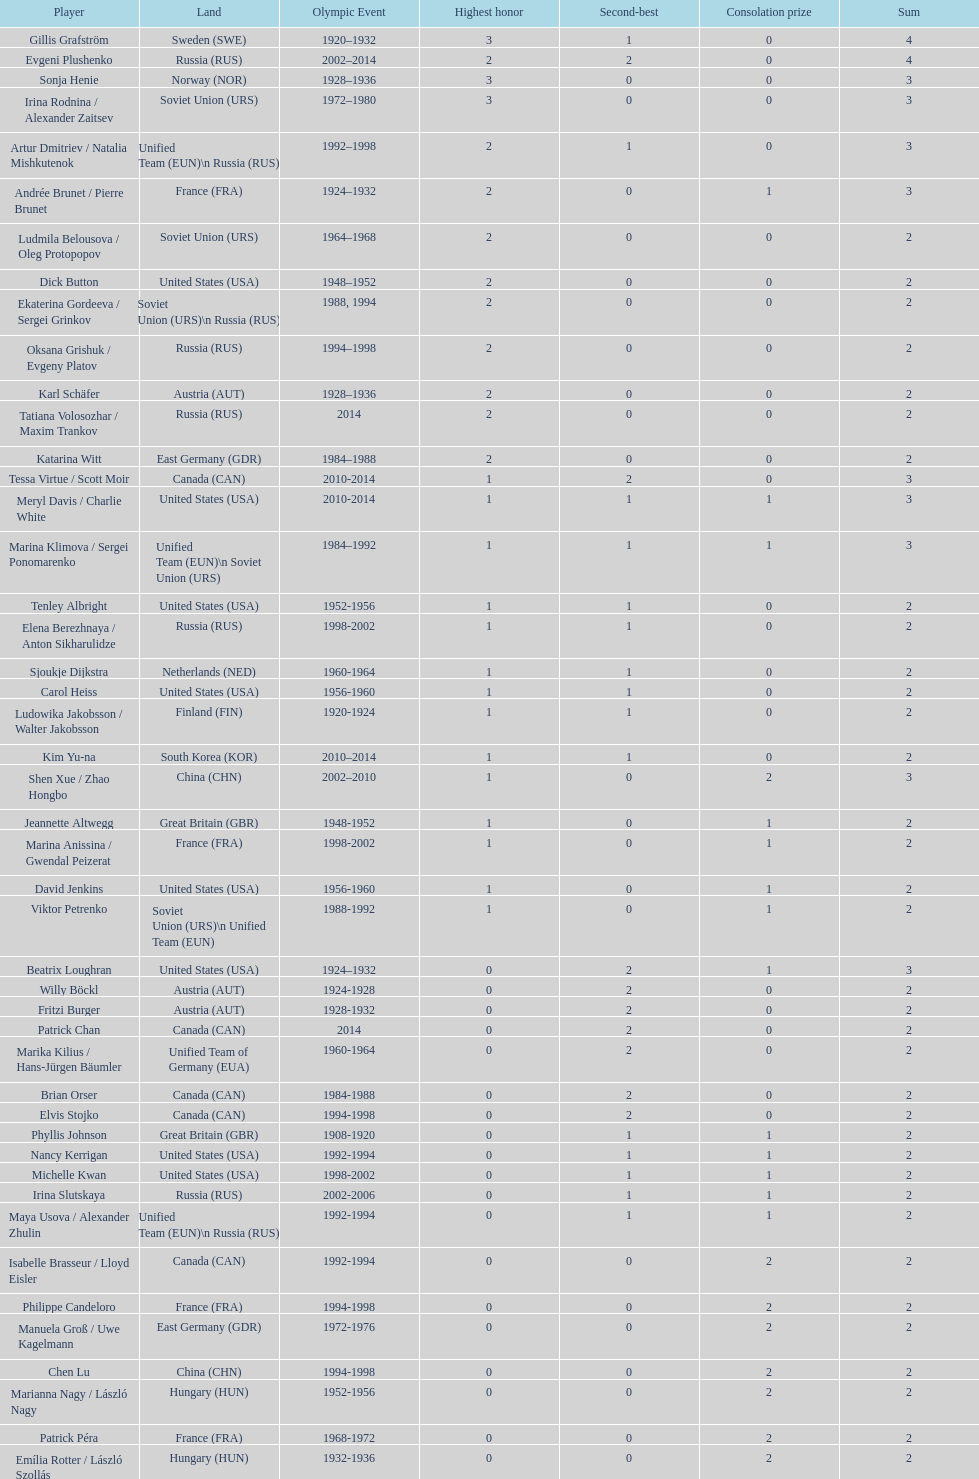Can you parse all the data within this table? {'header': ['Player', 'Land', 'Olympic Event', 'Highest honor', 'Second-best', 'Consolation prize', 'Sum'], 'rows': [['Gillis Grafström', 'Sweden\xa0(SWE)', '1920–1932', '3', '1', '0', '4'], ['Evgeni Plushenko', 'Russia\xa0(RUS)', '2002–2014', '2', '2', '0', '4'], ['Sonja Henie', 'Norway\xa0(NOR)', '1928–1936', '3', '0', '0', '3'], ['Irina Rodnina / Alexander Zaitsev', 'Soviet Union\xa0(URS)', '1972–1980', '3', '0', '0', '3'], ['Artur Dmitriev / Natalia Mishkutenok', 'Unified Team\xa0(EUN)\\n\xa0Russia\xa0(RUS)', '1992–1998', '2', '1', '0', '3'], ['Andrée Brunet / Pierre Brunet', 'France\xa0(FRA)', '1924–1932', '2', '0', '1', '3'], ['Ludmila Belousova / Oleg Protopopov', 'Soviet Union\xa0(URS)', '1964–1968', '2', '0', '0', '2'], ['Dick Button', 'United States\xa0(USA)', '1948–1952', '2', '0', '0', '2'], ['Ekaterina Gordeeva / Sergei Grinkov', 'Soviet Union\xa0(URS)\\n\xa0Russia\xa0(RUS)', '1988, 1994', '2', '0', '0', '2'], ['Oksana Grishuk / Evgeny Platov', 'Russia\xa0(RUS)', '1994–1998', '2', '0', '0', '2'], ['Karl Schäfer', 'Austria\xa0(AUT)', '1928–1936', '2', '0', '0', '2'], ['Tatiana Volosozhar / Maxim Trankov', 'Russia\xa0(RUS)', '2014', '2', '0', '0', '2'], ['Katarina Witt', 'East Germany\xa0(GDR)', '1984–1988', '2', '0', '0', '2'], ['Tessa Virtue / Scott Moir', 'Canada\xa0(CAN)', '2010-2014', '1', '2', '0', '3'], ['Meryl Davis / Charlie White', 'United States\xa0(USA)', '2010-2014', '1', '1', '1', '3'], ['Marina Klimova / Sergei Ponomarenko', 'Unified Team\xa0(EUN)\\n\xa0Soviet Union\xa0(URS)', '1984–1992', '1', '1', '1', '3'], ['Tenley Albright', 'United States\xa0(USA)', '1952-1956', '1', '1', '0', '2'], ['Elena Berezhnaya / Anton Sikharulidze', 'Russia\xa0(RUS)', '1998-2002', '1', '1', '0', '2'], ['Sjoukje Dijkstra', 'Netherlands\xa0(NED)', '1960-1964', '1', '1', '0', '2'], ['Carol Heiss', 'United States\xa0(USA)', '1956-1960', '1', '1', '0', '2'], ['Ludowika Jakobsson / Walter Jakobsson', 'Finland\xa0(FIN)', '1920-1924', '1', '1', '0', '2'], ['Kim Yu-na', 'South Korea\xa0(KOR)', '2010–2014', '1', '1', '0', '2'], ['Shen Xue / Zhao Hongbo', 'China\xa0(CHN)', '2002–2010', '1', '0', '2', '3'], ['Jeannette Altwegg', 'Great Britain\xa0(GBR)', '1948-1952', '1', '0', '1', '2'], ['Marina Anissina / Gwendal Peizerat', 'France\xa0(FRA)', '1998-2002', '1', '0', '1', '2'], ['David Jenkins', 'United States\xa0(USA)', '1956-1960', '1', '0', '1', '2'], ['Viktor Petrenko', 'Soviet Union\xa0(URS)\\n\xa0Unified Team\xa0(EUN)', '1988-1992', '1', '0', '1', '2'], ['Beatrix Loughran', 'United States\xa0(USA)', '1924–1932', '0', '2', '1', '3'], ['Willy Böckl', 'Austria\xa0(AUT)', '1924-1928', '0', '2', '0', '2'], ['Fritzi Burger', 'Austria\xa0(AUT)', '1928-1932', '0', '2', '0', '2'], ['Patrick Chan', 'Canada\xa0(CAN)', '2014', '0', '2', '0', '2'], ['Marika Kilius / Hans-Jürgen Bäumler', 'Unified Team of Germany\xa0(EUA)', '1960-1964', '0', '2', '0', '2'], ['Brian Orser', 'Canada\xa0(CAN)', '1984-1988', '0', '2', '0', '2'], ['Elvis Stojko', 'Canada\xa0(CAN)', '1994-1998', '0', '2', '0', '2'], ['Phyllis Johnson', 'Great Britain\xa0(GBR)', '1908-1920', '0', '1', '1', '2'], ['Nancy Kerrigan', 'United States\xa0(USA)', '1992-1994', '0', '1', '1', '2'], ['Michelle Kwan', 'United States\xa0(USA)', '1998-2002', '0', '1', '1', '2'], ['Irina Slutskaya', 'Russia\xa0(RUS)', '2002-2006', '0', '1', '1', '2'], ['Maya Usova / Alexander Zhulin', 'Unified Team\xa0(EUN)\\n\xa0Russia\xa0(RUS)', '1992-1994', '0', '1', '1', '2'], ['Isabelle Brasseur / Lloyd Eisler', 'Canada\xa0(CAN)', '1992-1994', '0', '0', '2', '2'], ['Philippe Candeloro', 'France\xa0(FRA)', '1994-1998', '0', '0', '2', '2'], ['Manuela Groß / Uwe Kagelmann', 'East Germany\xa0(GDR)', '1972-1976', '0', '0', '2', '2'], ['Chen Lu', 'China\xa0(CHN)', '1994-1998', '0', '0', '2', '2'], ['Marianna Nagy / László Nagy', 'Hungary\xa0(HUN)', '1952-1956', '0', '0', '2', '2'], ['Patrick Péra', 'France\xa0(FRA)', '1968-1972', '0', '0', '2', '2'], ['Emília Rotter / László Szollás', 'Hungary\xa0(HUN)', '1932-1936', '0', '0', '2', '2'], ['Aliona Savchenko / Robin Szolkowy', 'Germany\xa0(GER)', '2010-2014', '0', '0', '2', '2']]} How many more silver medals did gillis grafström have compared to sonja henie? 1. 